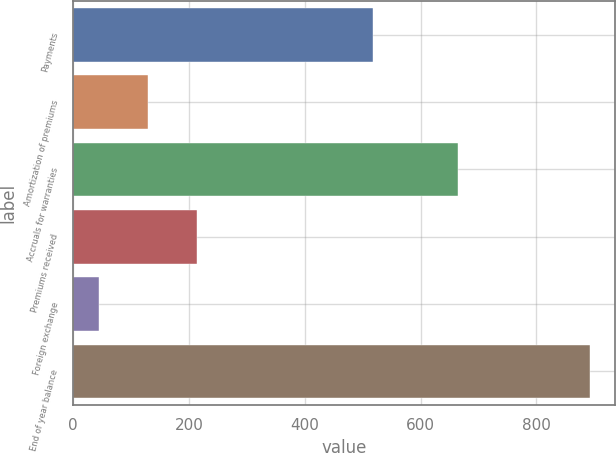Convert chart. <chart><loc_0><loc_0><loc_500><loc_500><bar_chart><fcel>Payments<fcel>Amortization of premiums<fcel>Accruals for warranties<fcel>Premiums received<fcel>Foreign exchange<fcel>End of year balance<nl><fcel>517<fcel>129.7<fcel>665<fcel>214.4<fcel>45<fcel>892<nl></chart> 